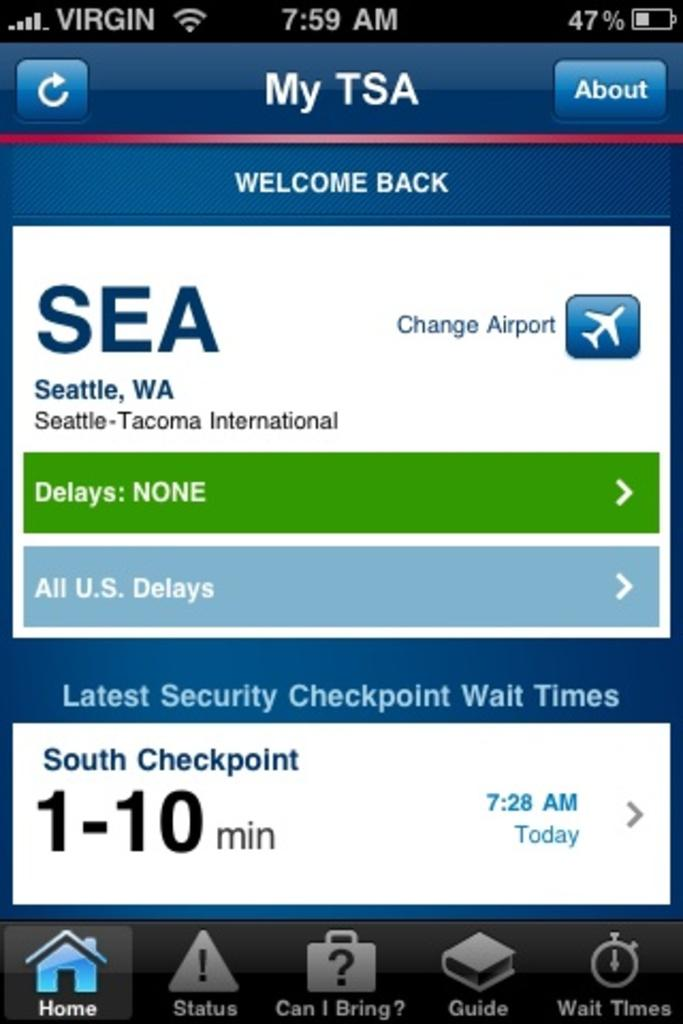<image>
Present a compact description of the photo's key features. TSA screen for an application displays the South Checkpoint as a 1-10 min wait time. 